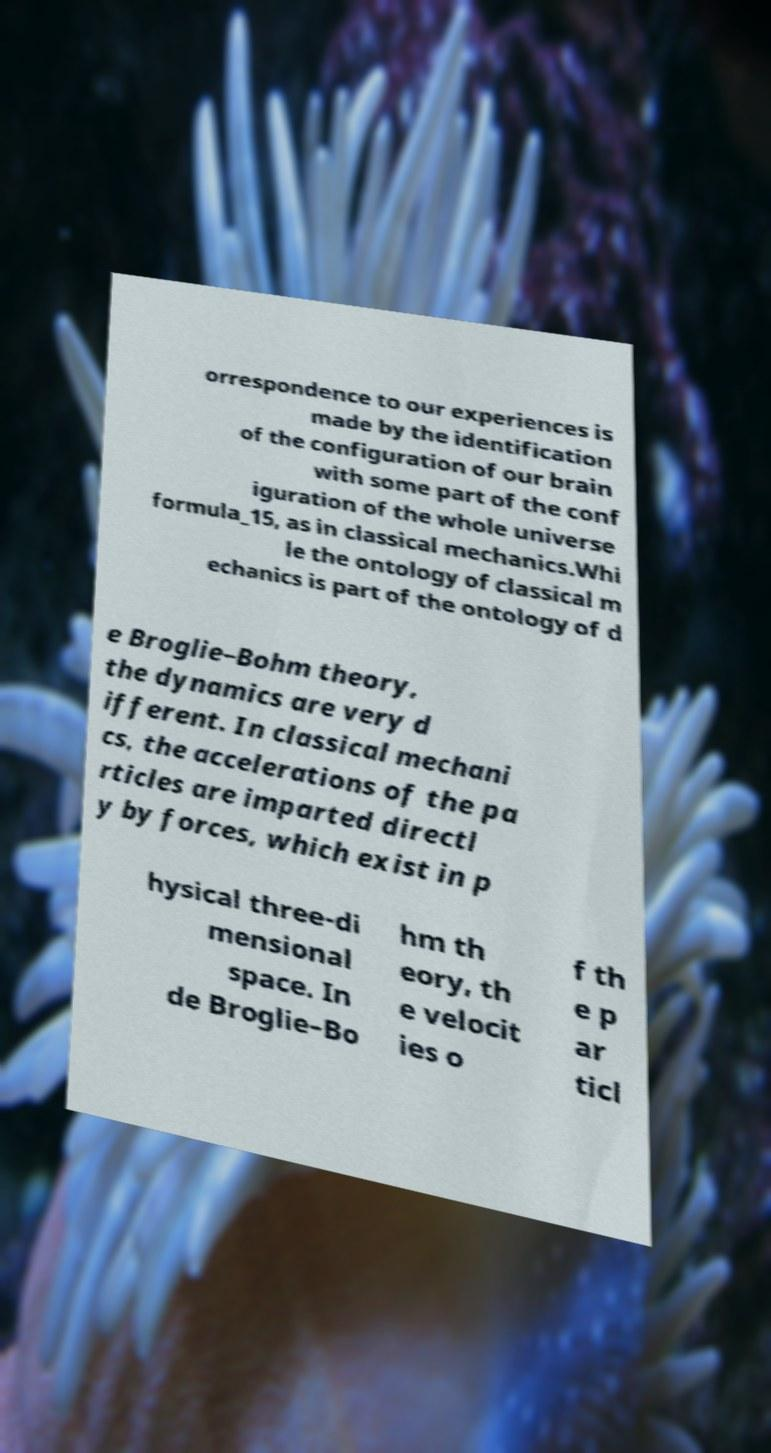I need the written content from this picture converted into text. Can you do that? orrespondence to our experiences is made by the identification of the configuration of our brain with some part of the conf iguration of the whole universe formula_15, as in classical mechanics.Whi le the ontology of classical m echanics is part of the ontology of d e Broglie–Bohm theory, the dynamics are very d ifferent. In classical mechani cs, the accelerations of the pa rticles are imparted directl y by forces, which exist in p hysical three-di mensional space. In de Broglie–Bo hm th eory, th e velocit ies o f th e p ar ticl 